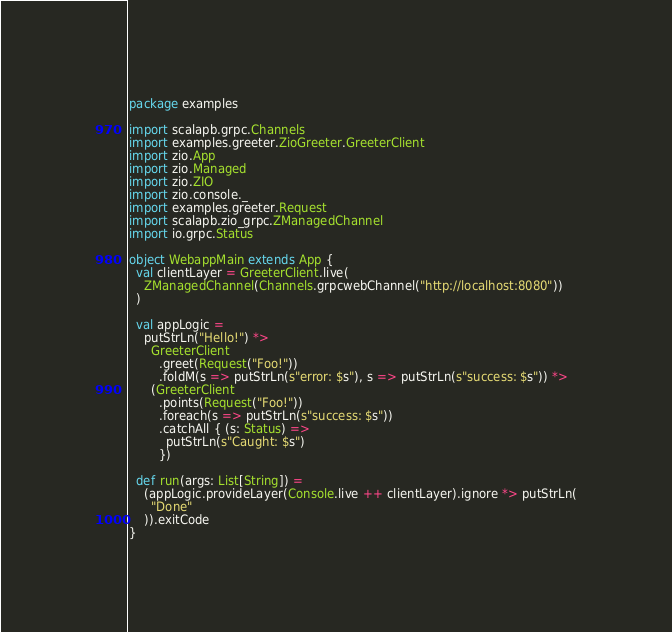Convert code to text. <code><loc_0><loc_0><loc_500><loc_500><_Scala_>package examples

import scalapb.grpc.Channels
import examples.greeter.ZioGreeter.GreeterClient
import zio.App
import zio.Managed
import zio.ZIO
import zio.console._
import examples.greeter.Request
import scalapb.zio_grpc.ZManagedChannel
import io.grpc.Status

object WebappMain extends App {
  val clientLayer = GreeterClient.live(
    ZManagedChannel(Channels.grpcwebChannel("http://localhost:8080"))
  )

  val appLogic =
    putStrLn("Hello!") *>
      GreeterClient
        .greet(Request("Foo!"))
        .foldM(s => putStrLn(s"error: $s"), s => putStrLn(s"success: $s")) *>
      (GreeterClient
        .points(Request("Foo!"))
        .foreach(s => putStrLn(s"success: $s"))
        .catchAll { (s: Status) =>
          putStrLn(s"Caught: $s")
        })

  def run(args: List[String]) =
    (appLogic.provideLayer(Console.live ++ clientLayer).ignore *> putStrLn(
      "Done"
    )).exitCode
}
</code> 